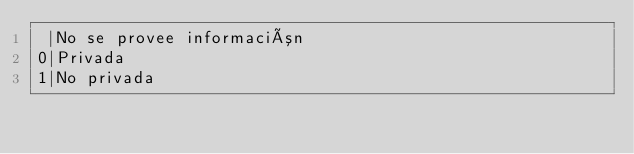Convert code to text. <code><loc_0><loc_0><loc_500><loc_500><_SQL_> |No se provee información
0|Privada
1|No privada </code> 